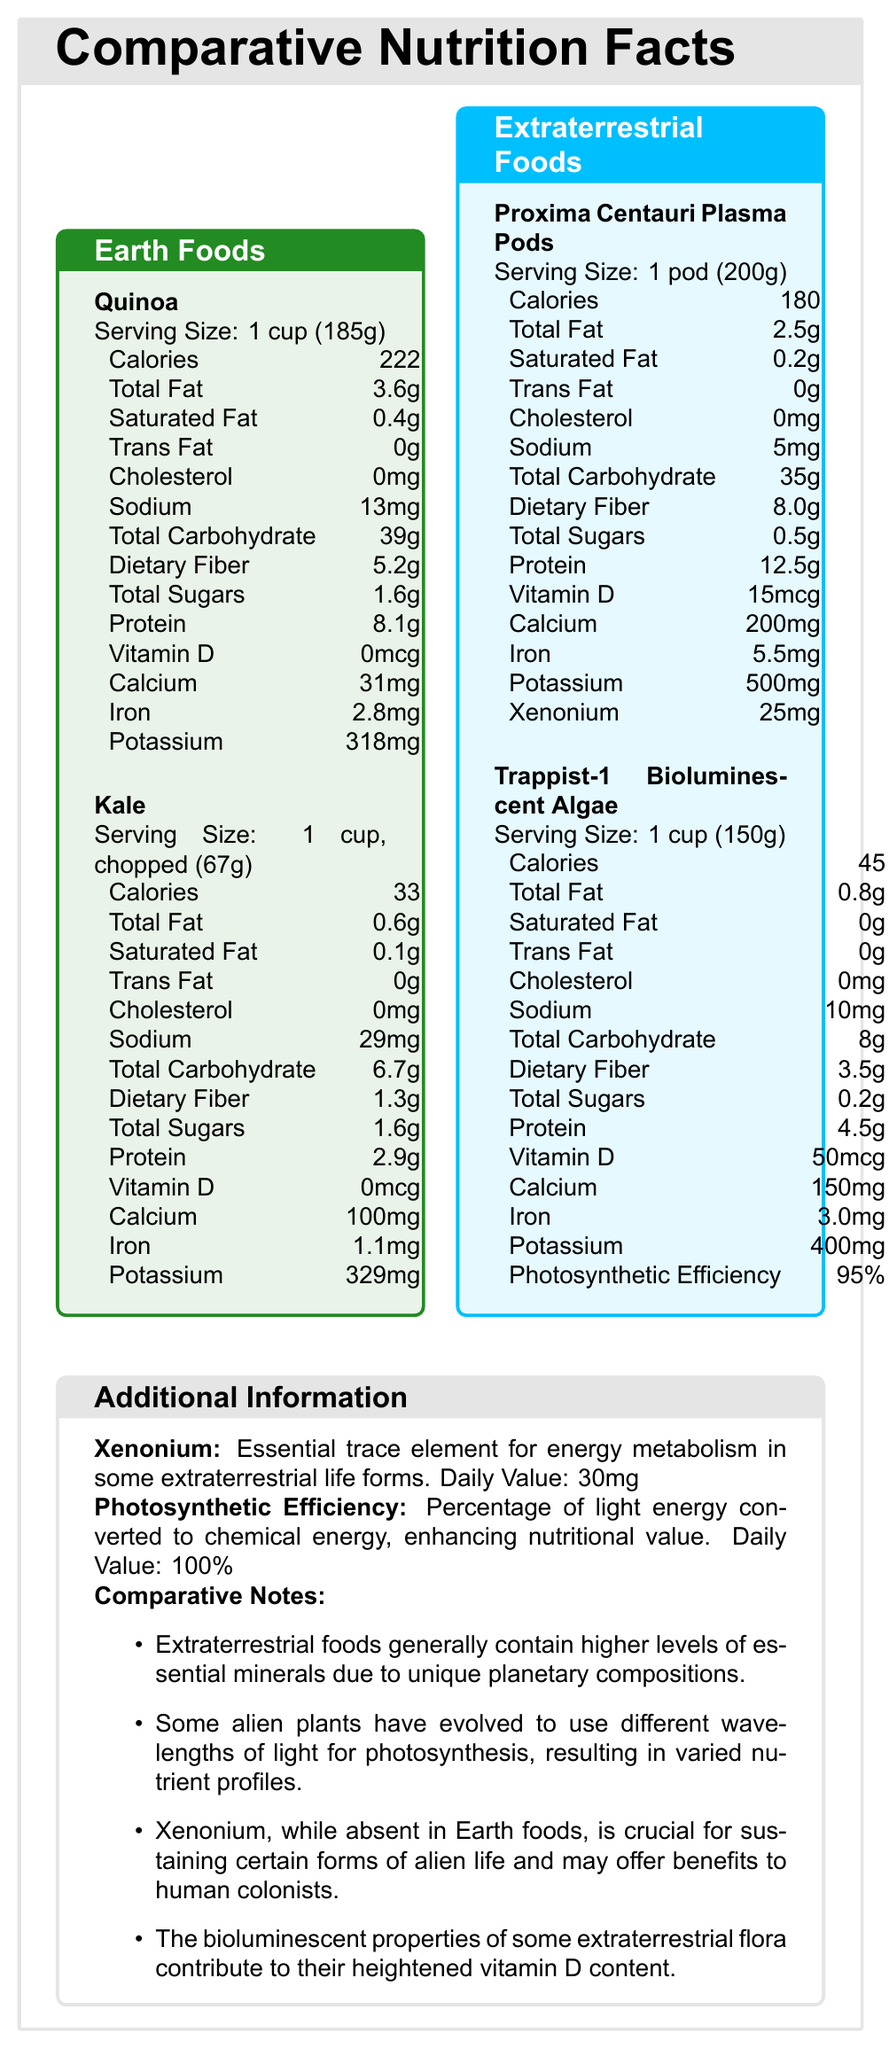How many grams of dietary fiber are in a serving of Proxima Centauri Plasma Pods? The nutritional table for Proxima Centauri Plasma Pods lists dietary fiber as 8.0 grams for a serving size of 1 pod (200g).
Answer: 8.0 grams Which food has the highest protein content per serving? Proxima Centauri Plasma Pods contain 12.5 grams of protein per serving, which is higher than Quinoa, Kale, and Trappist-1 Bioluminescent Algae.
Answer: Proxima Centauri Plasma Pods What is the serving size for Trappist-1 Bioluminescent Algae? The serving size for Trappist-1 Bioluminescent Algae is clearly stated as 1 cup (150g).
Answer: 1 cup (150g) List two unique nutrients found in the extraterrestrial foods section that are not present in the Earth foods section. Extraterrestrial foods include Xenonium and Photosynthetic Efficiency, which are absent in the Earth foods.
Answer: Xenonium, Photosynthetic Efficiency Which nutrient has a daily value of 100% in the document? A. Vitamin D B. Iron C. Photosynthetic Efficiency D. Xenonium The daily value of Photosynthetic Efficiency is listed as 100% in the additional information section.
Answer: C. Photosynthetic Efficiency Which of the following has the lowest calorie content per serving? i. Quinoa ii. Kale iii. Proxima Centauri Plasma Pods iv. Trappist-1 Bioluminescent Algae Kale has 33 calories per serving, which is lower than all the other listed foods.
Answer: ii. Kale Do extraterrestrial foods contain cholesterol? Both Proxima Centauri Plasma Pods and Trappist-1 Bioluminescent Algae have 0mg of cholesterol.
Answer: No What is the importance of Xenonium as detailed in the document? The additional information section explains that Xenonium is an essential trace element for energy metabolism in some extraterrestrial life forms and may benefit human colonists.
Answer: Essential trace element for energy metabolism in some extraterrestrial life forms Does Quinoa or Kale contain any trans fat? Both Quinoa and Kale are listed as having 0 grams of trans fat per serving.
Answer: No Summarize the main differences between Earth foods and extraterrestrial foods, based on the nutritional information provided. The document indicates that extraterrestrial foods have higher levels of minerals and unique nutrients specific to their planetary environments. Xenonium and high photosynthetic efficiency are notable properties in extraterrestrial foods, contributing to their nutritional profile.
Answer: Extraterrestrial foods generally contain higher levels of essential minerals, additional unique nutrients like Xenonium, and higher photosynthetic efficiency compared to Earth foods. What exact light wavelengths do Trappist-1 Bioluminescent Algae use for photosynthesis? The document mentions that some alien plants use different wavelengths of light for photosynthesis, but it does not specify the exact wavelengths used.
Answer: Cannot be determined 